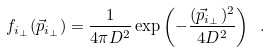<formula> <loc_0><loc_0><loc_500><loc_500>f _ { i _ { \perp } } ( { \vec { p } } _ { i _ { \perp } } ) = \frac { 1 } { 4 \pi D ^ { 2 } } \exp \left ( - \frac { ( { \vec { p } } _ { i _ { \perp } } ) ^ { 2 } } { 4 D ^ { 2 } } \right ) \ .</formula> 